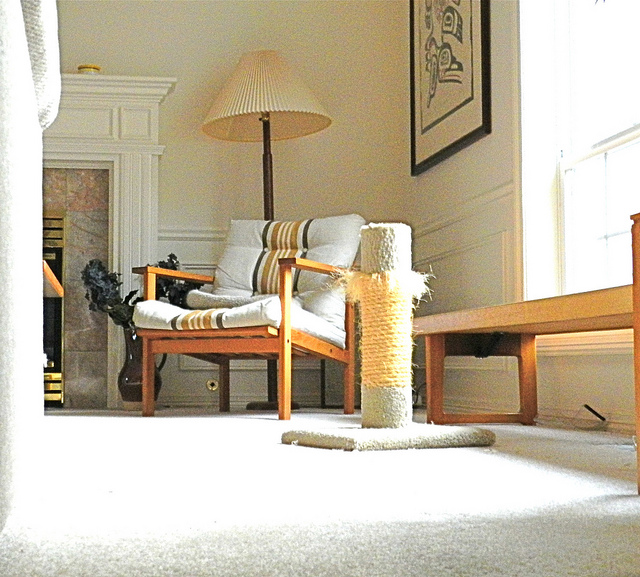<image>Who made the art on the wall? It is unknown who made the art on the wall. The artist could be Picasso or someone else. Who made the art on the wall? I am not sure who made the art on the wall. It can be an artist or Picasso. 